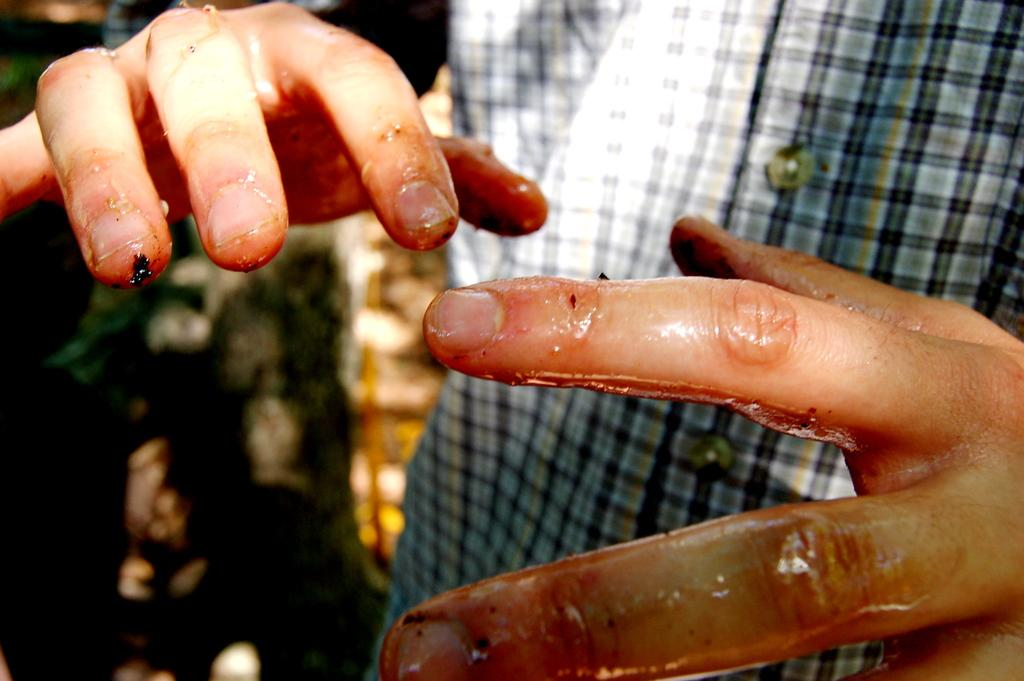What body part is visible in the image? There are hands of a man in the image. What substance is on the hands in the image? There is gel on the hands in the image. What type of pear is being sliced on the table in the image? There is no pear or table present in the image; it only shows hands with gel on them. 